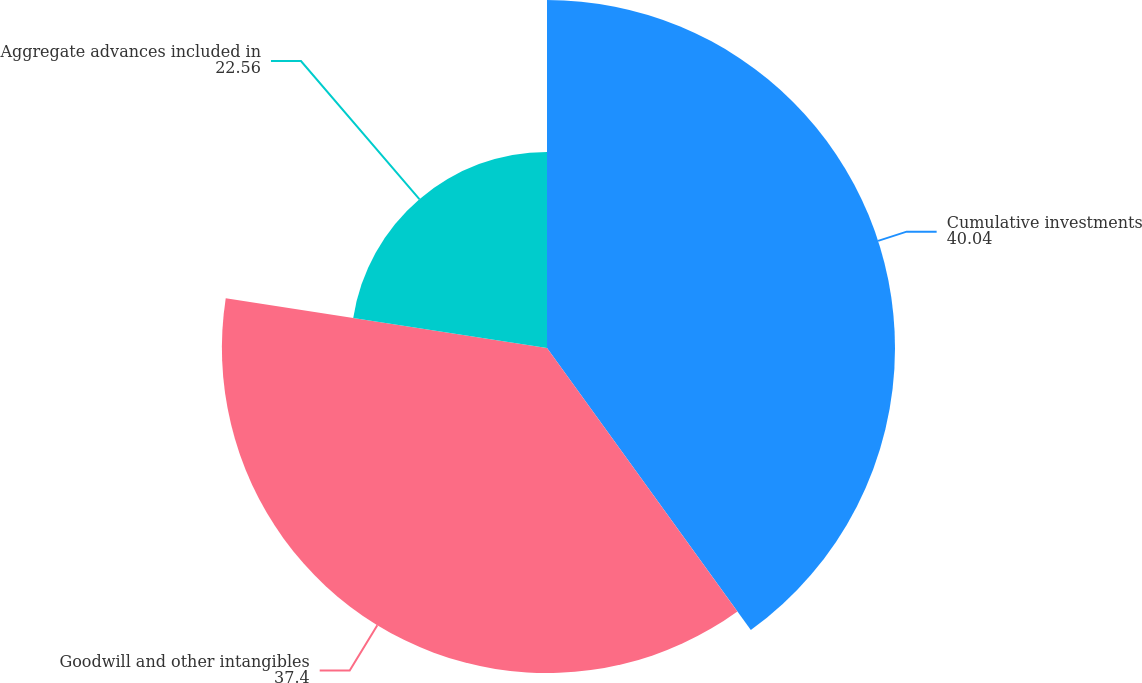<chart> <loc_0><loc_0><loc_500><loc_500><pie_chart><fcel>Cumulative investments<fcel>Goodwill and other intangibles<fcel>Aggregate advances included in<nl><fcel>40.04%<fcel>37.4%<fcel>22.56%<nl></chart> 